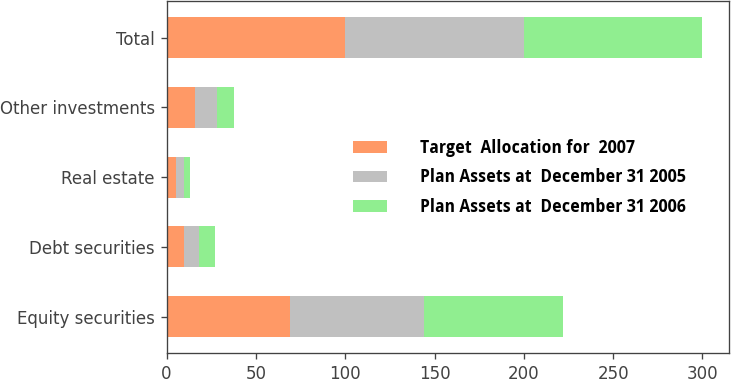<chart> <loc_0><loc_0><loc_500><loc_500><stacked_bar_chart><ecel><fcel>Equity securities<fcel>Debt securities<fcel>Real estate<fcel>Other investments<fcel>Total<nl><fcel>Target  Allocation for  2007<fcel>69<fcel>10<fcel>5<fcel>16<fcel>100<nl><fcel>Plan Assets at  December 31 2005<fcel>75<fcel>8<fcel>5<fcel>12<fcel>100<nl><fcel>Plan Assets at  December 31 2006<fcel>78<fcel>9<fcel>3<fcel>10<fcel>100<nl></chart> 